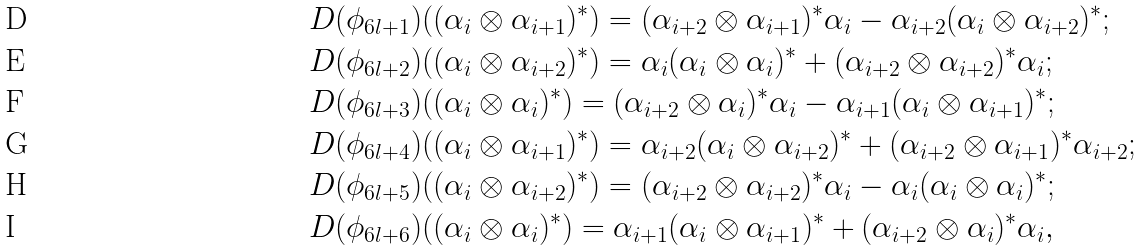Convert formula to latex. <formula><loc_0><loc_0><loc_500><loc_500>{ } & D ( \phi _ { 6 l + 1 } ) ( ( \alpha _ { i } \otimes \alpha _ { i + 1 } ) ^ { * } ) = ( \alpha _ { i + 2 } \otimes \alpha _ { i + 1 } ) ^ { * } \alpha _ { i } - \alpha _ { i + 2 } ( \alpha _ { i } \otimes \alpha _ { i + 2 } ) ^ { * } ; \\ & D ( \phi _ { 6 l + 2 } ) ( ( \alpha _ { i } \otimes \alpha _ { i + 2 } ) ^ { * } ) = \alpha _ { i } ( \alpha _ { i } \otimes \alpha _ { i } ) ^ { * } + ( \alpha _ { i + 2 } \otimes \alpha _ { i + 2 } ) ^ { * } \alpha _ { i } ; \\ & D ( \phi _ { 6 l + 3 } ) ( ( \alpha _ { i } \otimes \alpha _ { i } ) ^ { * } ) = ( \alpha _ { i + 2 } \otimes \alpha _ { i } ) ^ { * } \alpha _ { i } - \alpha _ { i + 1 } ( \alpha _ { i } \otimes \alpha _ { i + 1 } ) ^ { * } ; \\ & D ( \phi _ { 6 l + 4 } ) ( ( \alpha _ { i } \otimes \alpha _ { i + 1 } ) ^ { * } ) = \alpha _ { i + 2 } ( \alpha _ { i } \otimes \alpha _ { i + 2 } ) ^ { * } + ( \alpha _ { i + 2 } \otimes \alpha _ { i + 1 } ) ^ { * } \alpha _ { i + 2 } ; \\ & D ( \phi _ { 6 l + 5 } ) ( ( \alpha _ { i } \otimes \alpha _ { i + 2 } ) ^ { * } ) = ( \alpha _ { i + 2 } \otimes \alpha _ { i + 2 } ) ^ { * } \alpha _ { i } - \alpha _ { i } ( \alpha _ { i } \otimes \alpha _ { i } ) ^ { * } ; \\ & D ( \phi _ { 6 l + 6 } ) ( ( \alpha _ { i } \otimes \alpha _ { i } ) ^ { * } ) = \alpha _ { i + 1 } ( \alpha _ { i } \otimes \alpha _ { i + 1 } ) ^ { * } + ( \alpha _ { i + 2 } \otimes \alpha _ { i } ) ^ { * } \alpha _ { i } ,</formula> 